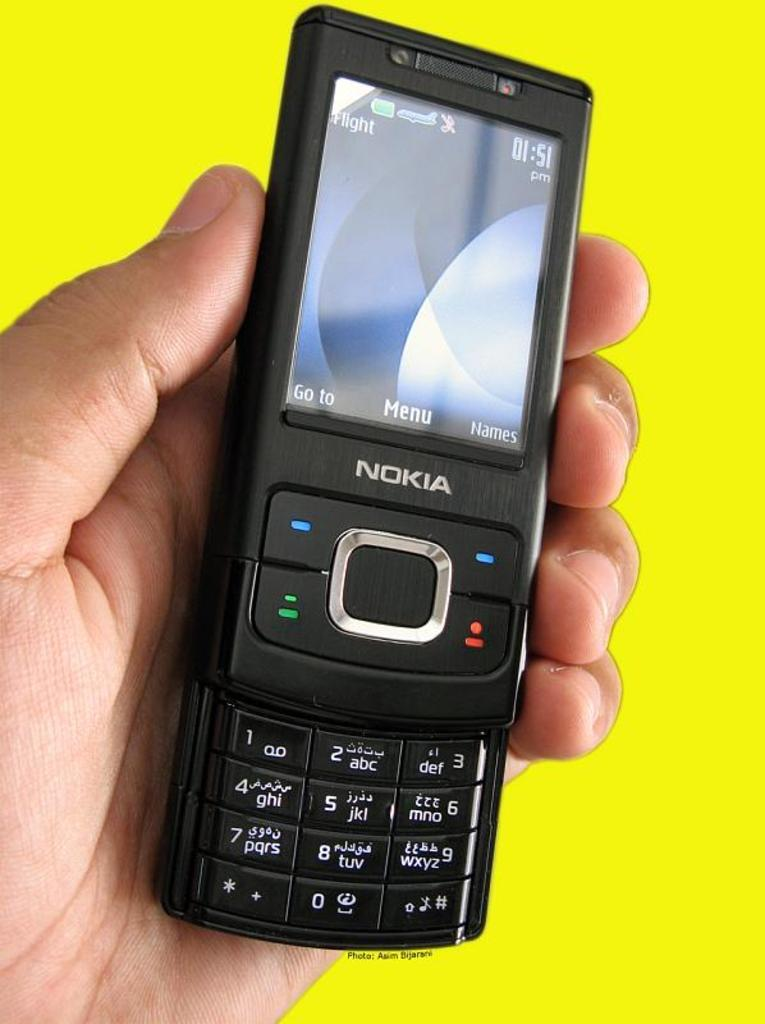Provide a one-sentence caption for the provided image. A close up of an old black Nokia phone showing the time as 01.51. 